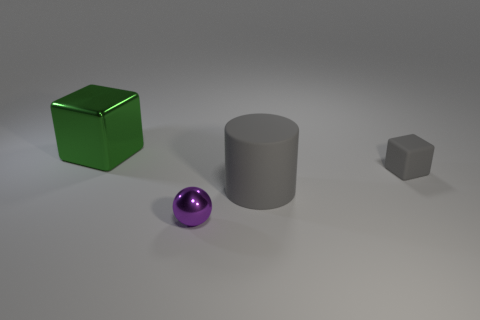Add 3 tiny brown rubber cylinders. How many objects exist? 7 Subtract all cylinders. How many objects are left? 3 Subtract 0 brown cubes. How many objects are left? 4 Subtract all purple shiny cubes. Subtract all green metal objects. How many objects are left? 3 Add 1 tiny purple balls. How many tiny purple balls are left? 2 Add 4 large matte things. How many large matte things exist? 5 